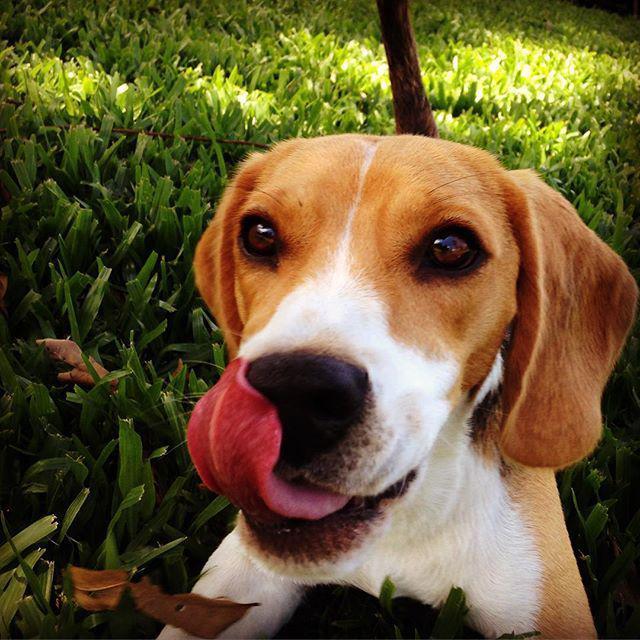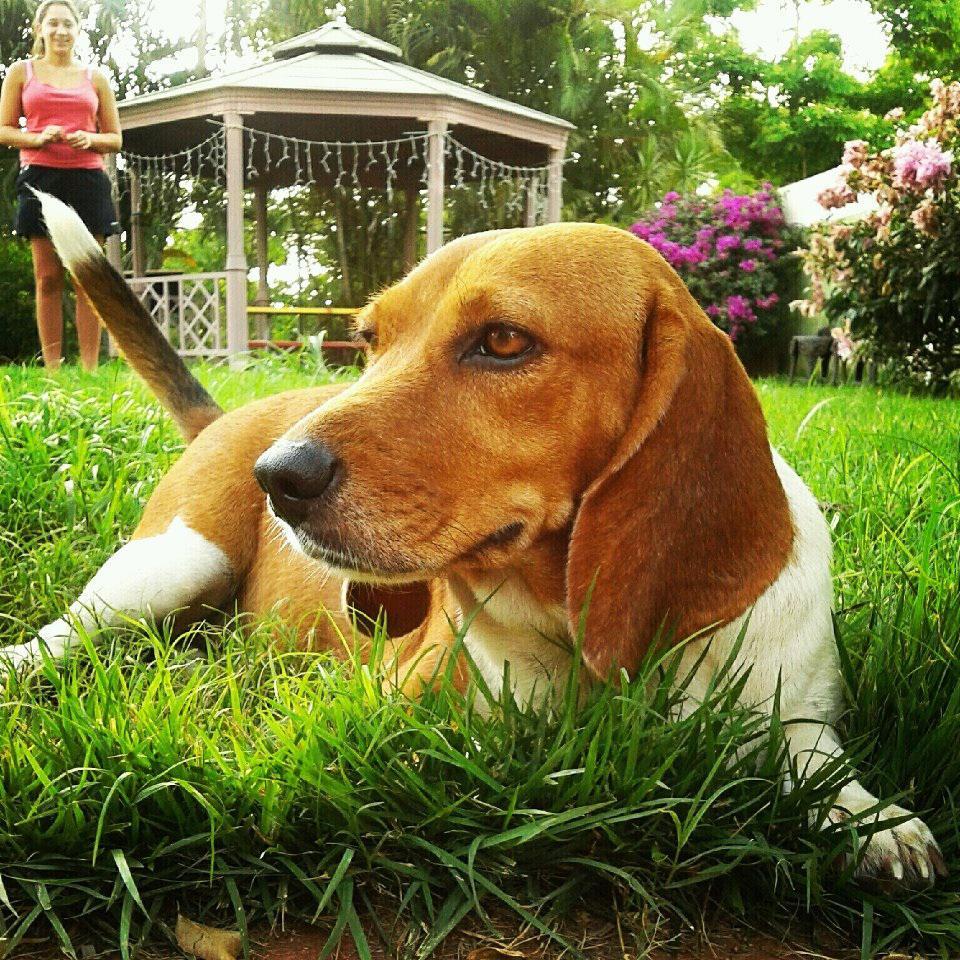The first image is the image on the left, the second image is the image on the right. For the images displayed, is the sentence "The left image shows one beagle with its tongue visible" factually correct? Answer yes or no. Yes. The first image is the image on the left, the second image is the image on the right. Given the left and right images, does the statement "There is a single dog lying in the grass in the image on the right." hold true? Answer yes or no. Yes. 